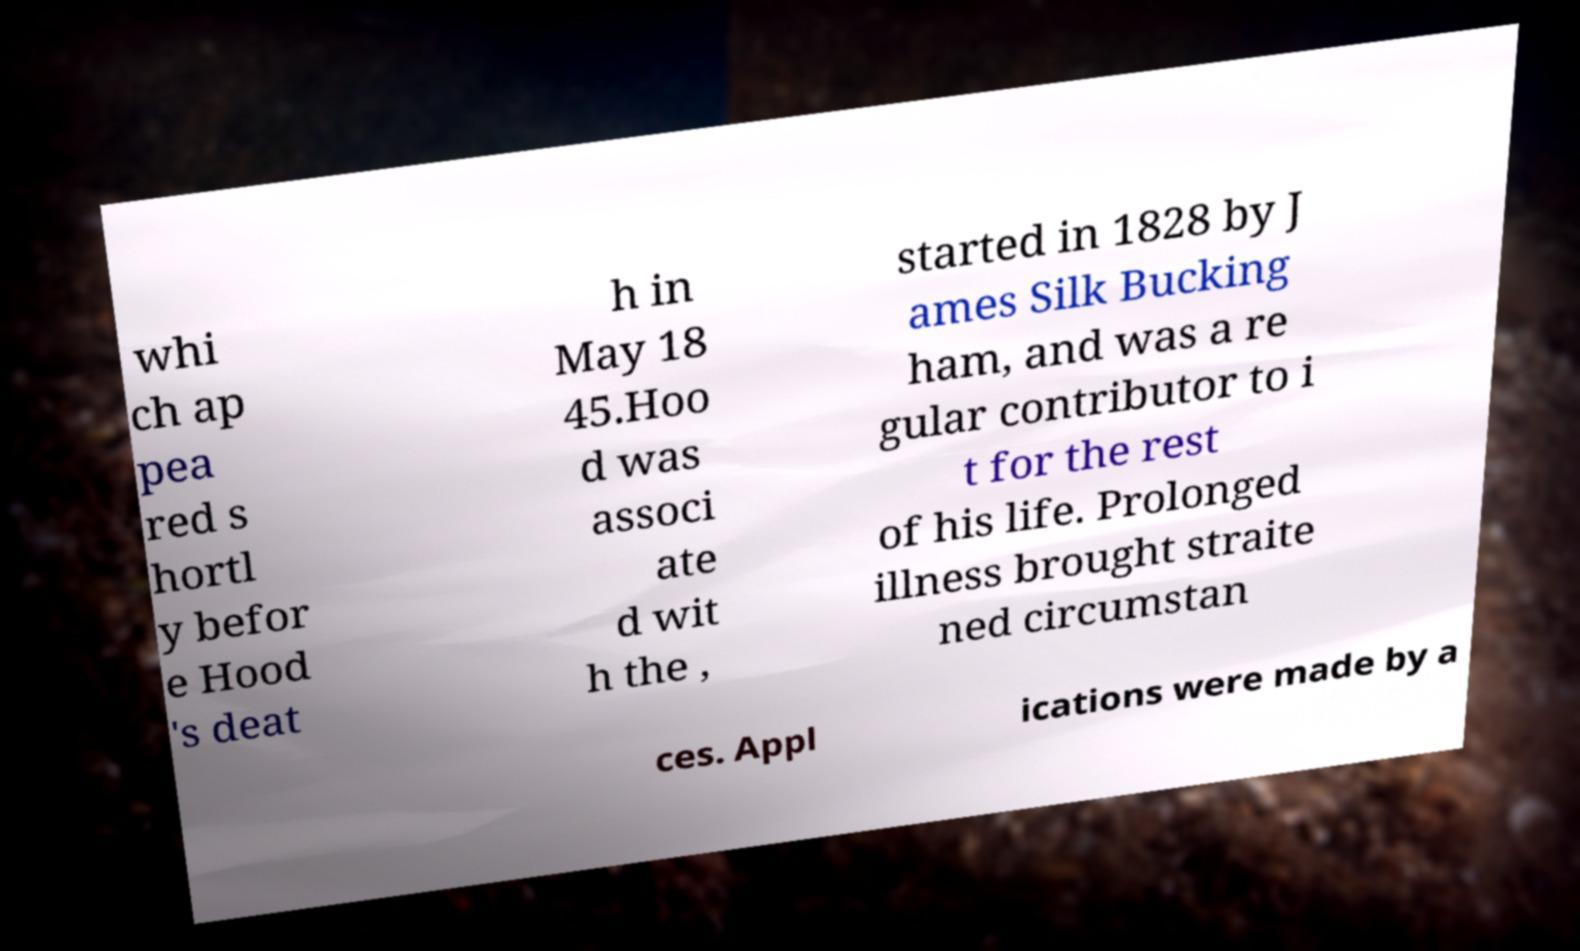I need the written content from this picture converted into text. Can you do that? whi ch ap pea red s hortl y befor e Hood 's deat h in May 18 45.Hoo d was associ ate d wit h the , started in 1828 by J ames Silk Bucking ham, and was a re gular contributor to i t for the rest of his life. Prolonged illness brought straite ned circumstan ces. Appl ications were made by a 